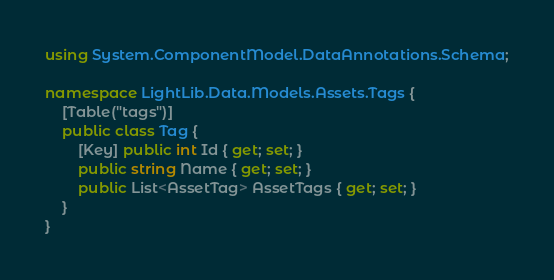<code> <loc_0><loc_0><loc_500><loc_500><_C#_>using System.ComponentModel.DataAnnotations.Schema;

namespace LightLib.Data.Models.Assets.Tags {
    [Table("tags")]
    public class Tag {
        [Key] public int Id { get; set; }
        public string Name { get; set; }
        public List<AssetTag> AssetTags { get; set; }
    }
}</code> 